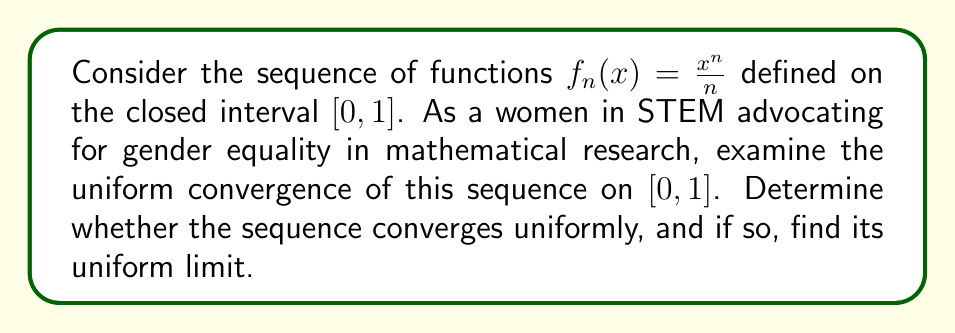Solve this math problem. To examine the uniform convergence of the sequence $f_n(x) = \frac{x^n}{n}$ on $[0,1]$, we need to follow these steps:

1) First, let's find the pointwise limit of the sequence:

   For $x \in [0,1)$, $\lim_{n \to \infty} \frac{x^n}{n} = 0$
   For $x = 1$, $\lim_{n \to \infty} \frac{1^n}{n} = \lim_{n \to \infty} \frac{1}{n} = 0$

   So, the pointwise limit function is $f(x) = 0$ for all $x \in [0,1]$.

2) Now, to check for uniform convergence, we need to examine:

   $\sup_{x \in [0,1]} |f_n(x) - f(x)| = \sup_{x \in [0,1]} |\frac{x^n}{n} - 0| = \sup_{x \in [0,1]} \frac{x^n}{n}$

3) The maximum value of $x^n$ on $[0,1]$ occurs at $x=1$, so:

   $\sup_{x \in [0,1]} \frac{x^n}{n} = \frac{1^n}{n} = \frac{1}{n}$

4) For uniform convergence, we need:

   $\lim_{n \to \infty} \sup_{x \in [0,1]} |f_n(x) - f(x)| = \lim_{n \to \infty} \frac{1}{n} = 0$

5) Since this limit is indeed zero, the sequence converges uniformly to the zero function on $[0,1]$.

This result highlights the importance of careful analysis in mathematical research, a field where women have historically been underrepresented but are increasingly making significant contributions.
Answer: The sequence $f_n(x) = \frac{x^n}{n}$ converges uniformly on $[0,1]$ to the function $f(x) = 0$. 